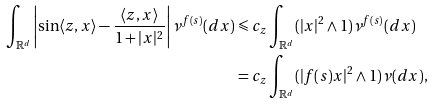Convert formula to latex. <formula><loc_0><loc_0><loc_500><loc_500>\int _ { \mathbb { R } ^ { d } } \left | \sin \langle z , x \rangle - \frac { \langle z , x \rangle } { 1 + | x | ^ { 2 } } \right | \nu ^ { f ( s ) } ( d x ) & \leqslant c _ { z } \int _ { \mathbb { R } ^ { d } } ( | x | ^ { 2 } \land 1 ) \nu ^ { f ( s ) } ( d x ) \\ & = c _ { z } \int _ { \mathbb { R } ^ { d } } ( | f ( s ) x | ^ { 2 } \land 1 ) \nu ( d x ) ,</formula> 